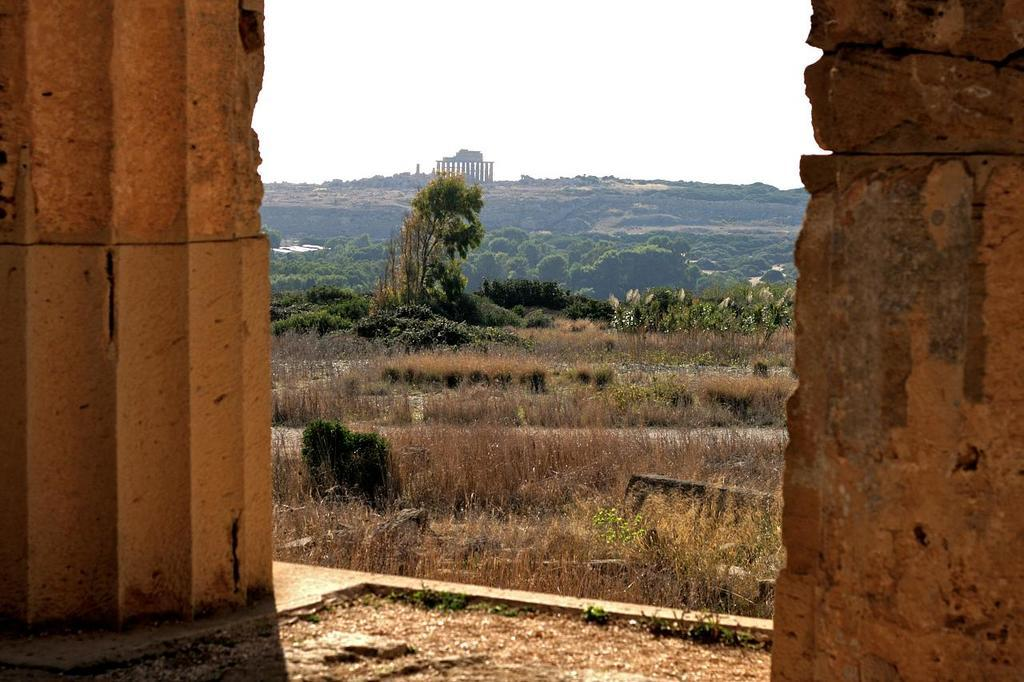Where was the image taken? The image was clicked outside. What can be seen in the image besides the walls on the left and right sides? There are many trees and plants, mountains, and the sky visible in the image. What is the income of the grandmother in the image? There is no grandmother present in the image, and therefore no information about her income can be provided. 